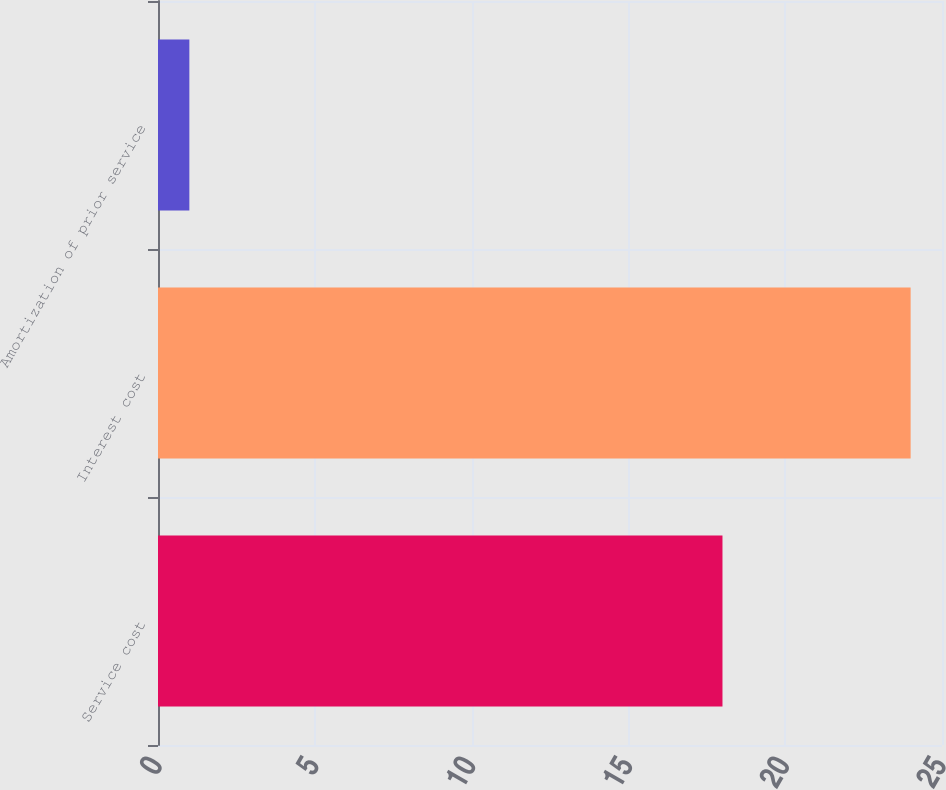<chart> <loc_0><loc_0><loc_500><loc_500><bar_chart><fcel>Service cost<fcel>Interest cost<fcel>Amortization of prior service<nl><fcel>18<fcel>24<fcel>1<nl></chart> 